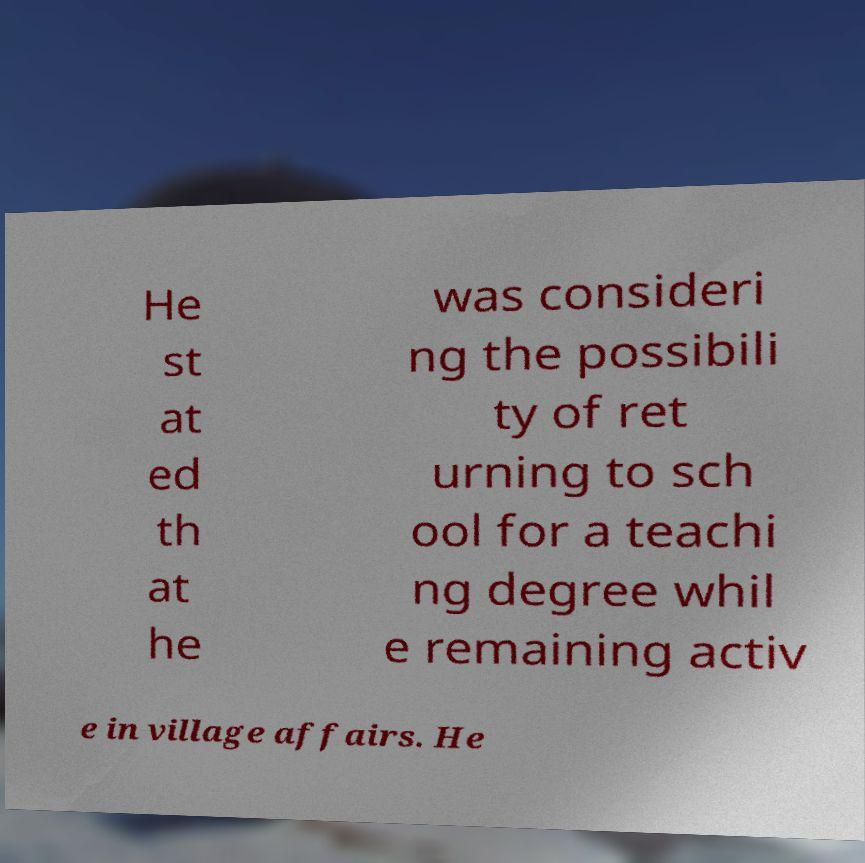There's text embedded in this image that I need extracted. Can you transcribe it verbatim? He st at ed th at he was consideri ng the possibili ty of ret urning to sch ool for a teachi ng degree whil e remaining activ e in village affairs. He 